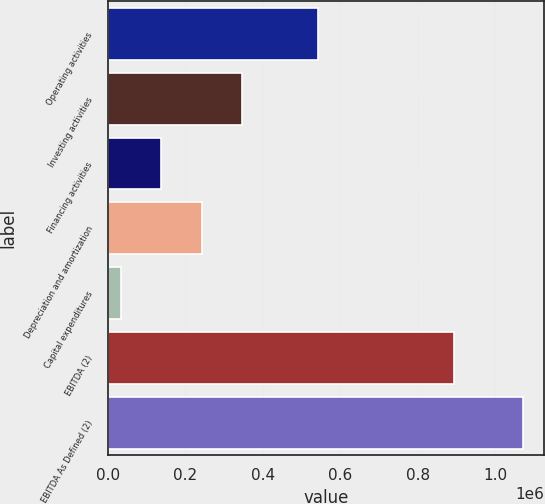Convert chart to OTSL. <chart><loc_0><loc_0><loc_500><loc_500><bar_chart><fcel>Operating activities<fcel>Investing activities<fcel>Financing activities<fcel>Depreciation and amortization<fcel>Capital expenditures<fcel>EBITDA (2)<fcel>EBITDA As Defined (2)<nl><fcel>541222<fcel>345864<fcel>138052<fcel>241958<fcel>34146<fcel>892583<fcel>1.07321e+06<nl></chart> 